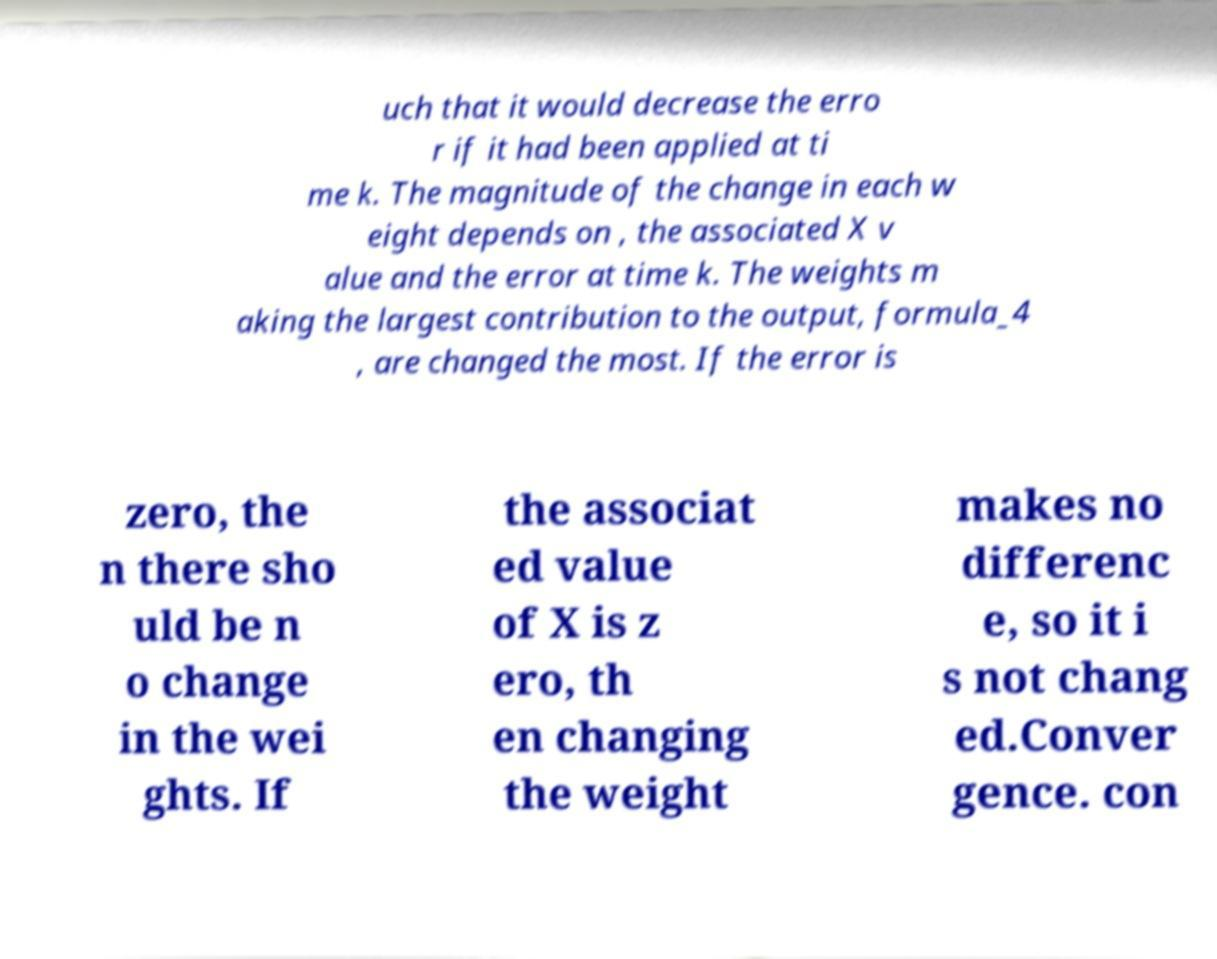For documentation purposes, I need the text within this image transcribed. Could you provide that? uch that it would decrease the erro r if it had been applied at ti me k. The magnitude of the change in each w eight depends on , the associated X v alue and the error at time k. The weights m aking the largest contribution to the output, formula_4 , are changed the most. If the error is zero, the n there sho uld be n o change in the wei ghts. If the associat ed value of X is z ero, th en changing the weight makes no differenc e, so it i s not chang ed.Conver gence. con 